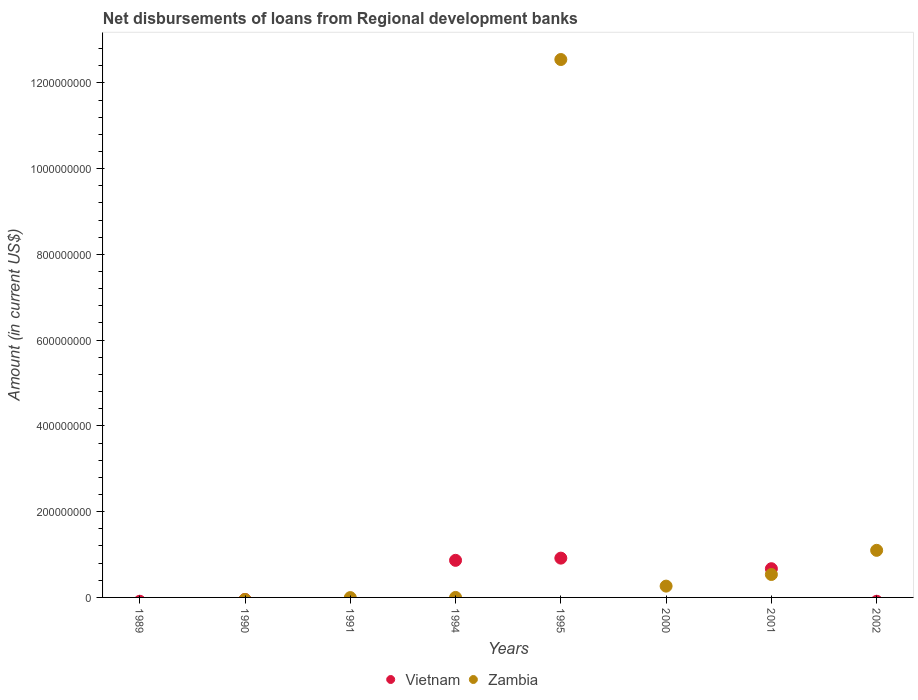Is the number of dotlines equal to the number of legend labels?
Offer a terse response. No. What is the amount of disbursements of loans from regional development banks in Zambia in 1990?
Keep it short and to the point. 0. Across all years, what is the maximum amount of disbursements of loans from regional development banks in Vietnam?
Give a very brief answer. 9.16e+07. Across all years, what is the minimum amount of disbursements of loans from regional development banks in Zambia?
Provide a short and direct response. 0. What is the total amount of disbursements of loans from regional development banks in Vietnam in the graph?
Give a very brief answer. 2.45e+08. What is the difference between the amount of disbursements of loans from regional development banks in Vietnam in 1995 and that in 2001?
Ensure brevity in your answer.  2.47e+07. What is the difference between the amount of disbursements of loans from regional development banks in Vietnam in 1990 and the amount of disbursements of loans from regional development banks in Zambia in 2000?
Provide a succinct answer. -2.64e+07. What is the average amount of disbursements of loans from regional development banks in Zambia per year?
Make the answer very short. 1.81e+08. In the year 2001, what is the difference between the amount of disbursements of loans from regional development banks in Vietnam and amount of disbursements of loans from regional development banks in Zambia?
Give a very brief answer. 1.35e+07. In how many years, is the amount of disbursements of loans from regional development banks in Vietnam greater than 360000000 US$?
Make the answer very short. 0. Is the difference between the amount of disbursements of loans from regional development banks in Vietnam in 1995 and 2001 greater than the difference between the amount of disbursements of loans from regional development banks in Zambia in 1995 and 2001?
Provide a short and direct response. No. What is the difference between the highest and the second highest amount of disbursements of loans from regional development banks in Vietnam?
Ensure brevity in your answer.  5.14e+06. What is the difference between the highest and the lowest amount of disbursements of loans from regional development banks in Zambia?
Make the answer very short. 1.25e+09. In how many years, is the amount of disbursements of loans from regional development banks in Vietnam greater than the average amount of disbursements of loans from regional development banks in Vietnam taken over all years?
Your answer should be compact. 3. How many dotlines are there?
Provide a succinct answer. 2. Does the graph contain grids?
Provide a succinct answer. No. Where does the legend appear in the graph?
Offer a terse response. Bottom center. How many legend labels are there?
Ensure brevity in your answer.  2. How are the legend labels stacked?
Your response must be concise. Horizontal. What is the title of the graph?
Offer a very short reply. Net disbursements of loans from Regional development banks. Does "Cambodia" appear as one of the legend labels in the graph?
Your answer should be very brief. No. What is the label or title of the X-axis?
Provide a short and direct response. Years. What is the Amount (in current US$) in Zambia in 1989?
Keep it short and to the point. 0. What is the Amount (in current US$) in Vietnam in 1990?
Provide a succinct answer. 0. What is the Amount (in current US$) in Zambia in 1990?
Your answer should be compact. 0. What is the Amount (in current US$) of Zambia in 1991?
Your answer should be compact. 0. What is the Amount (in current US$) of Vietnam in 1994?
Keep it short and to the point. 8.65e+07. What is the Amount (in current US$) in Zambia in 1994?
Provide a short and direct response. 0. What is the Amount (in current US$) in Vietnam in 1995?
Your answer should be very brief. 9.16e+07. What is the Amount (in current US$) in Zambia in 1995?
Your answer should be compact. 1.25e+09. What is the Amount (in current US$) in Vietnam in 2000?
Offer a terse response. 0. What is the Amount (in current US$) of Zambia in 2000?
Your answer should be compact. 2.64e+07. What is the Amount (in current US$) in Vietnam in 2001?
Your answer should be compact. 6.70e+07. What is the Amount (in current US$) in Zambia in 2001?
Your response must be concise. 5.35e+07. What is the Amount (in current US$) of Vietnam in 2002?
Provide a short and direct response. 0. What is the Amount (in current US$) in Zambia in 2002?
Give a very brief answer. 1.10e+08. Across all years, what is the maximum Amount (in current US$) in Vietnam?
Offer a terse response. 9.16e+07. Across all years, what is the maximum Amount (in current US$) of Zambia?
Provide a succinct answer. 1.25e+09. Across all years, what is the minimum Amount (in current US$) of Zambia?
Your answer should be very brief. 0. What is the total Amount (in current US$) in Vietnam in the graph?
Your response must be concise. 2.45e+08. What is the total Amount (in current US$) in Zambia in the graph?
Your answer should be compact. 1.44e+09. What is the difference between the Amount (in current US$) in Vietnam in 1994 and that in 1995?
Keep it short and to the point. -5.14e+06. What is the difference between the Amount (in current US$) of Vietnam in 1994 and that in 2001?
Your answer should be very brief. 1.95e+07. What is the difference between the Amount (in current US$) in Zambia in 1995 and that in 2000?
Your answer should be very brief. 1.23e+09. What is the difference between the Amount (in current US$) in Vietnam in 1995 and that in 2001?
Keep it short and to the point. 2.47e+07. What is the difference between the Amount (in current US$) in Zambia in 1995 and that in 2001?
Your answer should be compact. 1.20e+09. What is the difference between the Amount (in current US$) of Zambia in 1995 and that in 2002?
Provide a short and direct response. 1.14e+09. What is the difference between the Amount (in current US$) of Zambia in 2000 and that in 2001?
Offer a terse response. -2.71e+07. What is the difference between the Amount (in current US$) in Zambia in 2000 and that in 2002?
Provide a succinct answer. -8.34e+07. What is the difference between the Amount (in current US$) in Zambia in 2001 and that in 2002?
Your answer should be very brief. -5.63e+07. What is the difference between the Amount (in current US$) of Vietnam in 1994 and the Amount (in current US$) of Zambia in 1995?
Keep it short and to the point. -1.17e+09. What is the difference between the Amount (in current US$) in Vietnam in 1994 and the Amount (in current US$) in Zambia in 2000?
Offer a very short reply. 6.01e+07. What is the difference between the Amount (in current US$) of Vietnam in 1994 and the Amount (in current US$) of Zambia in 2001?
Provide a succinct answer. 3.30e+07. What is the difference between the Amount (in current US$) of Vietnam in 1994 and the Amount (in current US$) of Zambia in 2002?
Your answer should be compact. -2.33e+07. What is the difference between the Amount (in current US$) in Vietnam in 1995 and the Amount (in current US$) in Zambia in 2000?
Keep it short and to the point. 6.53e+07. What is the difference between the Amount (in current US$) of Vietnam in 1995 and the Amount (in current US$) of Zambia in 2001?
Offer a terse response. 3.81e+07. What is the difference between the Amount (in current US$) of Vietnam in 1995 and the Amount (in current US$) of Zambia in 2002?
Your response must be concise. -1.82e+07. What is the difference between the Amount (in current US$) in Vietnam in 2001 and the Amount (in current US$) in Zambia in 2002?
Your response must be concise. -4.29e+07. What is the average Amount (in current US$) of Vietnam per year?
Ensure brevity in your answer.  3.06e+07. What is the average Amount (in current US$) in Zambia per year?
Keep it short and to the point. 1.81e+08. In the year 1995, what is the difference between the Amount (in current US$) of Vietnam and Amount (in current US$) of Zambia?
Provide a short and direct response. -1.16e+09. In the year 2001, what is the difference between the Amount (in current US$) in Vietnam and Amount (in current US$) in Zambia?
Offer a terse response. 1.35e+07. What is the ratio of the Amount (in current US$) in Vietnam in 1994 to that in 1995?
Offer a terse response. 0.94. What is the ratio of the Amount (in current US$) of Vietnam in 1994 to that in 2001?
Provide a succinct answer. 1.29. What is the ratio of the Amount (in current US$) of Zambia in 1995 to that in 2000?
Keep it short and to the point. 47.55. What is the ratio of the Amount (in current US$) in Vietnam in 1995 to that in 2001?
Offer a terse response. 1.37. What is the ratio of the Amount (in current US$) of Zambia in 1995 to that in 2001?
Offer a very short reply. 23.45. What is the ratio of the Amount (in current US$) of Zambia in 1995 to that in 2002?
Keep it short and to the point. 11.42. What is the ratio of the Amount (in current US$) in Zambia in 2000 to that in 2001?
Your answer should be very brief. 0.49. What is the ratio of the Amount (in current US$) of Zambia in 2000 to that in 2002?
Offer a very short reply. 0.24. What is the ratio of the Amount (in current US$) of Zambia in 2001 to that in 2002?
Provide a short and direct response. 0.49. What is the difference between the highest and the second highest Amount (in current US$) of Vietnam?
Your response must be concise. 5.14e+06. What is the difference between the highest and the second highest Amount (in current US$) in Zambia?
Provide a succinct answer. 1.14e+09. What is the difference between the highest and the lowest Amount (in current US$) of Vietnam?
Ensure brevity in your answer.  9.16e+07. What is the difference between the highest and the lowest Amount (in current US$) of Zambia?
Keep it short and to the point. 1.25e+09. 